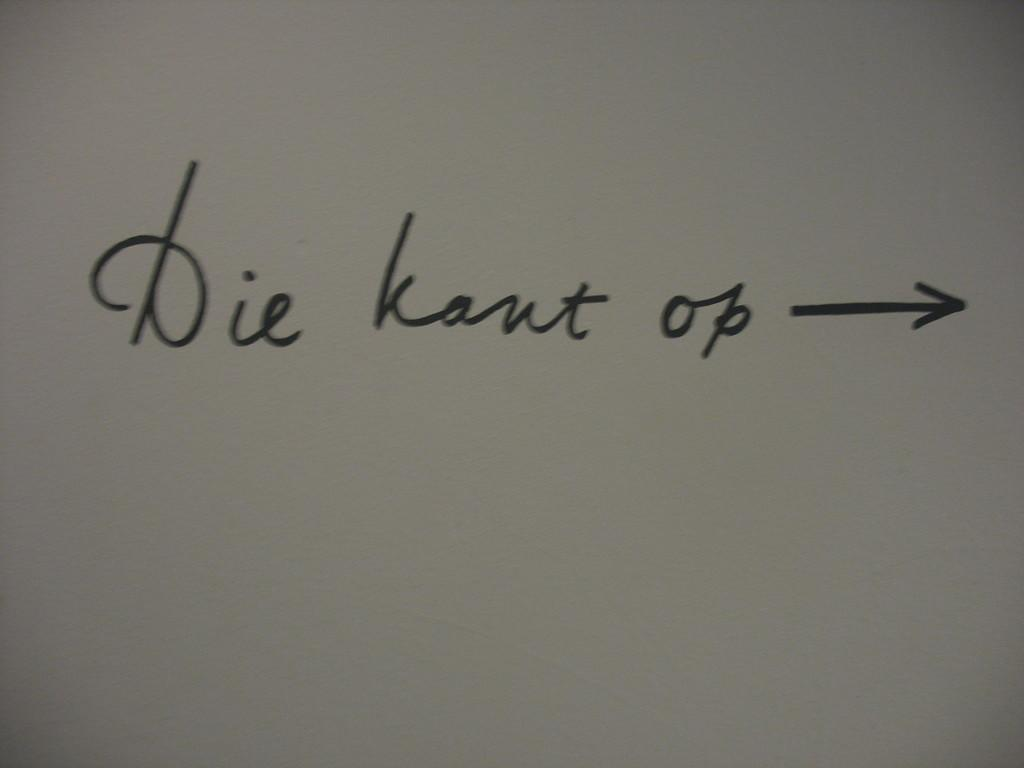<image>
Offer a succinct explanation of the picture presented. Some cursive writing with an arrow, one of the words being Die. 